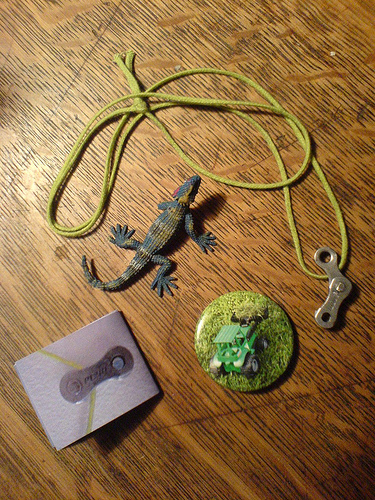<image>
Is the button on the string? No. The button is not positioned on the string. They may be near each other, but the button is not supported by or resting on top of the string. 